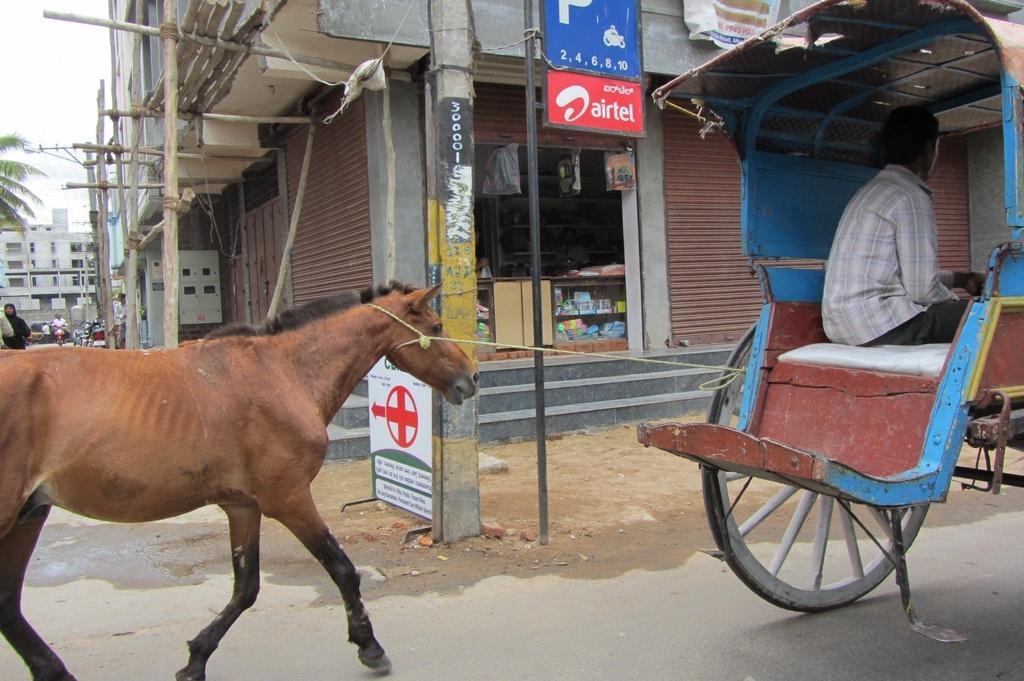Could you give a brief overview of what you see in this image? In the picture we can see a house building with a shop to it near it we can see a pole with a board and near it we can see a road and on it we can see a cart with a man sitting in it and a horse behind it which is tied to the cart and the horse is brown in color and behind it we can see a building and a part of tree and a sky. 